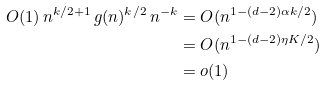<formula> <loc_0><loc_0><loc_500><loc_500>O ( 1 ) \, n ^ { k / 2 + 1 } \, g ( n ) ^ { k / 2 } \, n ^ { - k } & = O ( n ^ { 1 - ( d - 2 ) \alpha k / 2 } ) \\ & = O ( n ^ { 1 - ( d - 2 ) \eta K / 2 } ) \\ & = o ( 1 )</formula> 